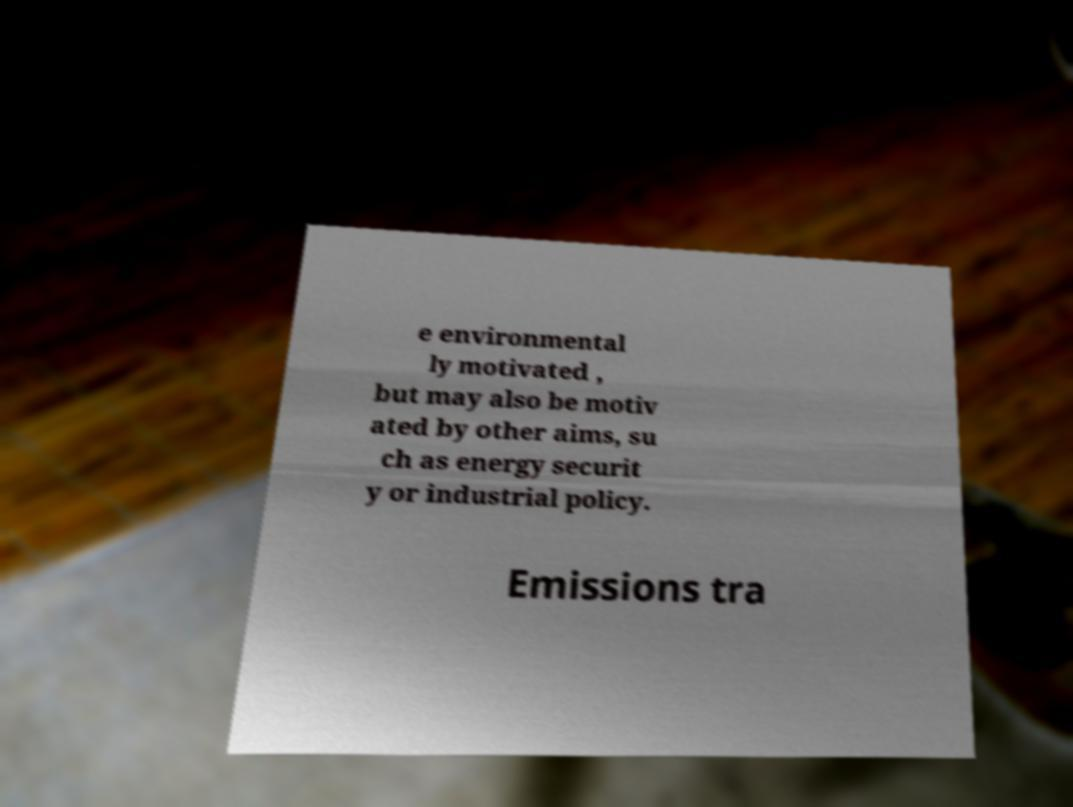Can you read and provide the text displayed in the image?This photo seems to have some interesting text. Can you extract and type it out for me? e environmental ly motivated , but may also be motiv ated by other aims, su ch as energy securit y or industrial policy. Emissions tra 